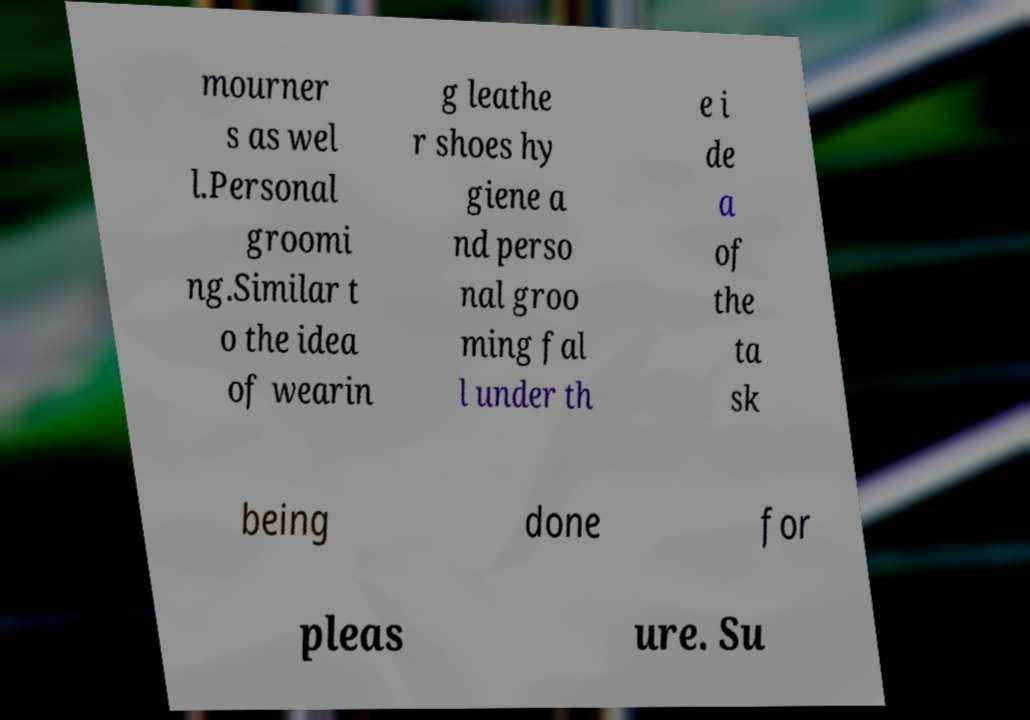Can you accurately transcribe the text from the provided image for me? mourner s as wel l.Personal groomi ng.Similar t o the idea of wearin g leathe r shoes hy giene a nd perso nal groo ming fal l under th e i de a of the ta sk being done for pleas ure. Su 